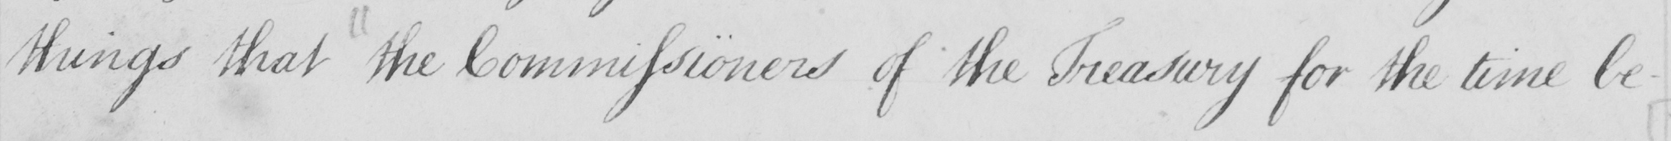What is written in this line of handwriting? things that the Commissioners of the Treasury for the time be- 